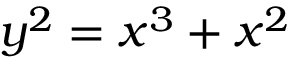Convert formula to latex. <formula><loc_0><loc_0><loc_500><loc_500>y ^ { 2 } = x ^ { 3 } + x ^ { 2 }</formula> 